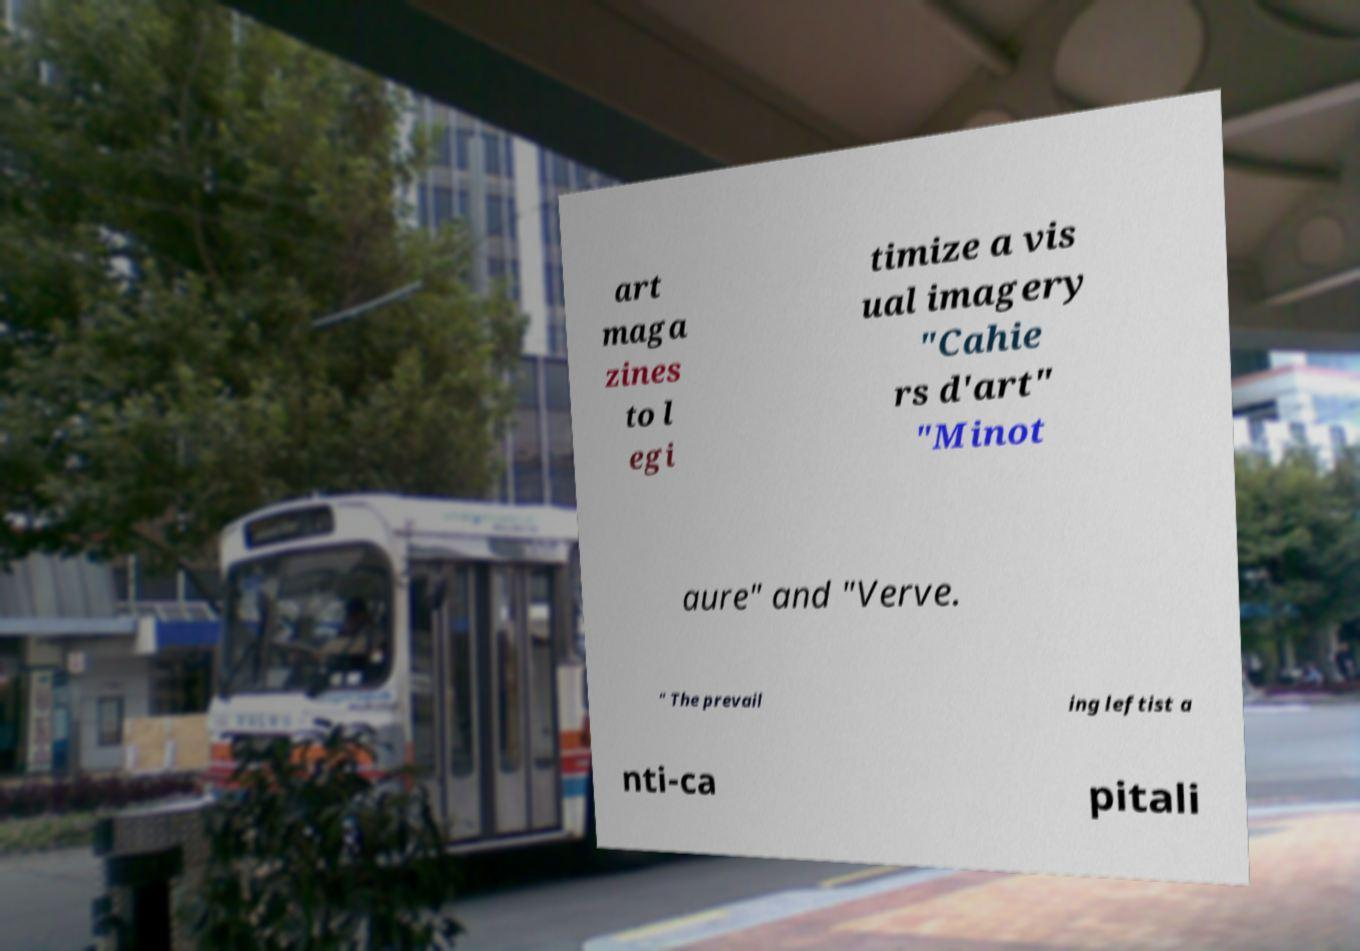Can you accurately transcribe the text from the provided image for me? art maga zines to l egi timize a vis ual imagery "Cahie rs d'art" "Minot aure" and "Verve. " The prevail ing leftist a nti-ca pitali 